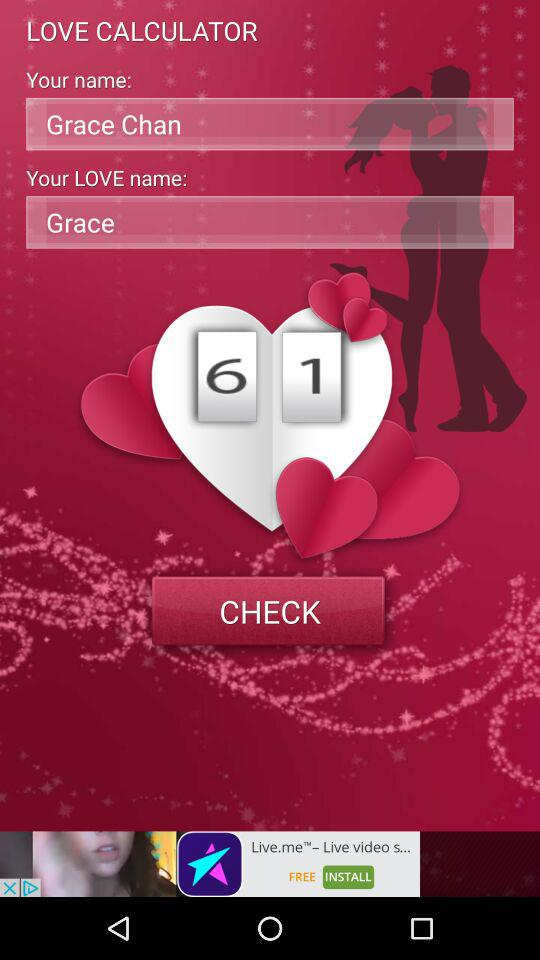What is the app name? The app name is "LOVE CALCULATOR". 